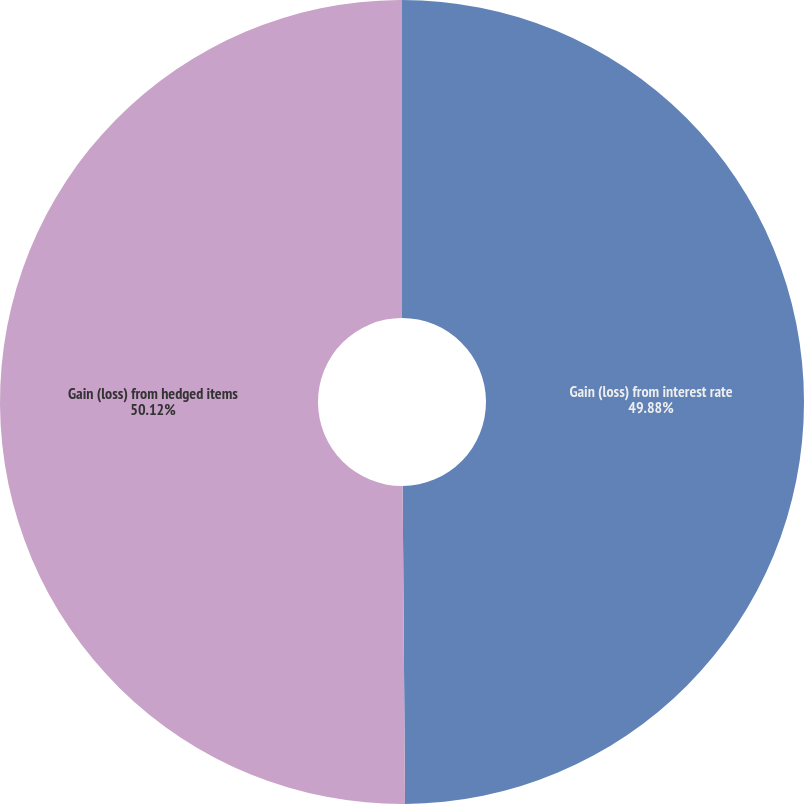Convert chart to OTSL. <chart><loc_0><loc_0><loc_500><loc_500><pie_chart><fcel>Gain (loss) from interest rate<fcel>Gain (loss) from hedged items<nl><fcel>49.88%<fcel>50.12%<nl></chart> 